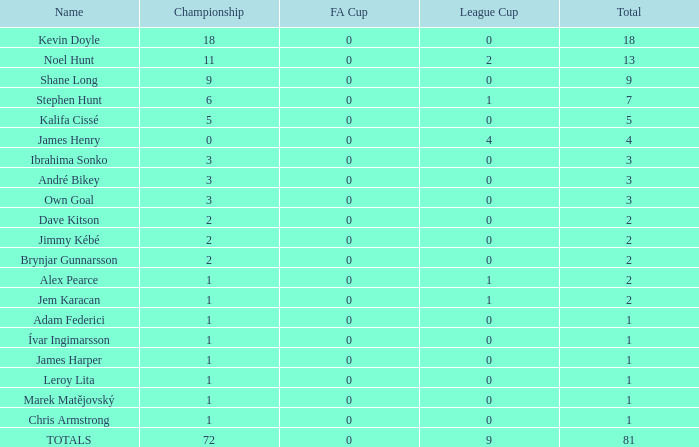Could you parse the entire table as a dict? {'header': ['Name', 'Championship', 'FA Cup', 'League Cup', 'Total'], 'rows': [['Kevin Doyle', '18', '0', '0', '18'], ['Noel Hunt', '11', '0', '2', '13'], ['Shane Long', '9', '0', '0', '9'], ['Stephen Hunt', '6', '0', '1', '7'], ['Kalifa Cissé', '5', '0', '0', '5'], ['James Henry', '0', '0', '4', '4'], ['Ibrahima Sonko', '3', '0', '0', '3'], ['André Bikey', '3', '0', '0', '3'], ['Own Goal', '3', '0', '0', '3'], ['Dave Kitson', '2', '0', '0', '2'], ['Jimmy Kébé', '2', '0', '0', '2'], ['Brynjar Gunnarsson', '2', '0', '0', '2'], ['Alex Pearce', '1', '0', '1', '2'], ['Jem Karacan', '1', '0', '1', '2'], ['Adam Federici', '1', '0', '0', '1'], ['Ívar Ingimarsson', '1', '0', '0', '1'], ['James Harper', '1', '0', '0', '1'], ['Leroy Lita', '1', '0', '0', '1'], ['Marek Matějovský', '1', '0', '0', '1'], ['Chris Armstrong', '1', '0', '0', '1'], ['TOTALS', '72', '0', '9', '81']]} What is the championship of Jem Karacan that has a total of 2 and a league cup more than 0? 1.0. 